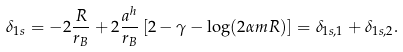<formula> <loc_0><loc_0><loc_500><loc_500>\delta _ { 1 s } = - 2 \frac { R } { r _ { B } } + 2 \frac { a ^ { h } } { r _ { B } } \left [ 2 - \gamma - \log ( 2 \alpha m R ) \right ] = \delta _ { 1 s , 1 } + \delta _ { 1 s , 2 } .</formula> 